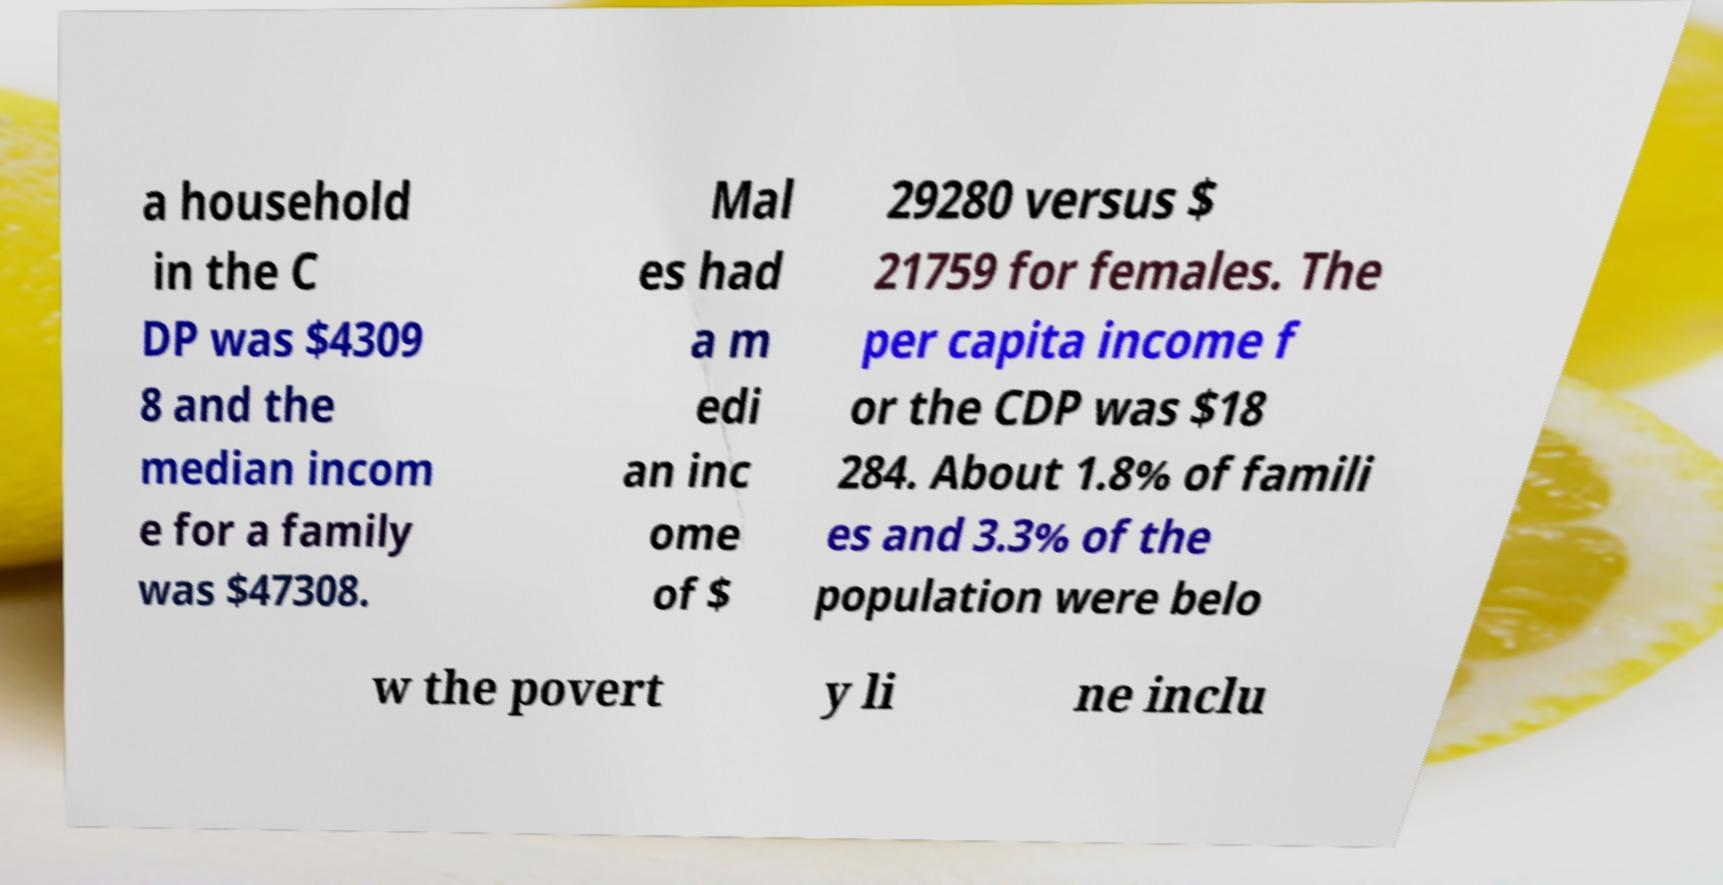Could you extract and type out the text from this image? a household in the C DP was $4309 8 and the median incom e for a family was $47308. Mal es had a m edi an inc ome of $ 29280 versus $ 21759 for females. The per capita income f or the CDP was $18 284. About 1.8% of famili es and 3.3% of the population were belo w the povert y li ne inclu 